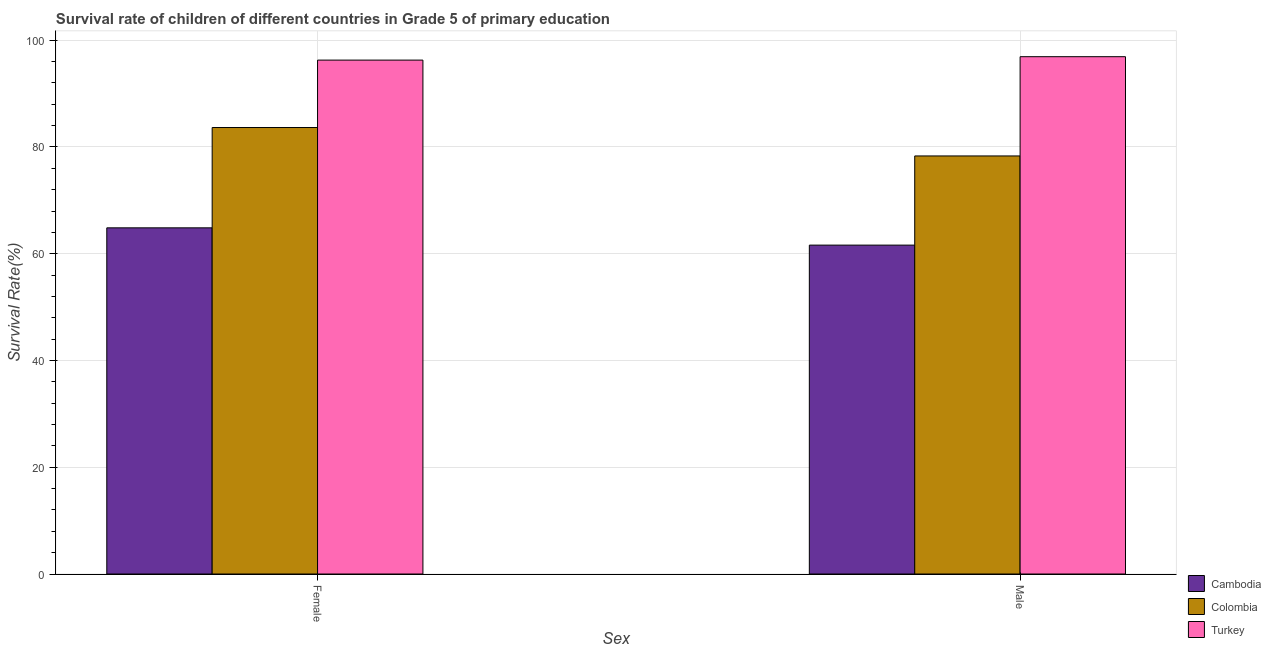How many different coloured bars are there?
Your answer should be compact. 3. How many groups of bars are there?
Offer a terse response. 2. Are the number of bars per tick equal to the number of legend labels?
Provide a short and direct response. Yes. How many bars are there on the 2nd tick from the right?
Make the answer very short. 3. What is the survival rate of female students in primary education in Colombia?
Offer a terse response. 83.64. Across all countries, what is the maximum survival rate of female students in primary education?
Make the answer very short. 96.27. Across all countries, what is the minimum survival rate of male students in primary education?
Offer a terse response. 61.61. In which country was the survival rate of male students in primary education maximum?
Give a very brief answer. Turkey. In which country was the survival rate of female students in primary education minimum?
Offer a very short reply. Cambodia. What is the total survival rate of male students in primary education in the graph?
Provide a short and direct response. 236.85. What is the difference between the survival rate of female students in primary education in Colombia and that in Cambodia?
Provide a short and direct response. 18.79. What is the difference between the survival rate of female students in primary education in Colombia and the survival rate of male students in primary education in Turkey?
Keep it short and to the point. -13.27. What is the average survival rate of male students in primary education per country?
Your response must be concise. 78.95. What is the difference between the survival rate of female students in primary education and survival rate of male students in primary education in Turkey?
Make the answer very short. -0.64. In how many countries, is the survival rate of female students in primary education greater than 76 %?
Your answer should be very brief. 2. What is the ratio of the survival rate of female students in primary education in Colombia to that in Cambodia?
Make the answer very short. 1.29. Is the survival rate of male students in primary education in Cambodia less than that in Turkey?
Provide a short and direct response. Yes. In how many countries, is the survival rate of female students in primary education greater than the average survival rate of female students in primary education taken over all countries?
Give a very brief answer. 2. What does the 3rd bar from the left in Male represents?
Offer a terse response. Turkey. What does the 3rd bar from the right in Female represents?
Ensure brevity in your answer.  Cambodia. Are all the bars in the graph horizontal?
Keep it short and to the point. No. How many countries are there in the graph?
Make the answer very short. 3. Are the values on the major ticks of Y-axis written in scientific E-notation?
Your response must be concise. No. Does the graph contain any zero values?
Your answer should be compact. No. Where does the legend appear in the graph?
Make the answer very short. Bottom right. How are the legend labels stacked?
Give a very brief answer. Vertical. What is the title of the graph?
Give a very brief answer. Survival rate of children of different countries in Grade 5 of primary education. What is the label or title of the X-axis?
Provide a short and direct response. Sex. What is the label or title of the Y-axis?
Keep it short and to the point. Survival Rate(%). What is the Survival Rate(%) in Cambodia in Female?
Offer a terse response. 64.85. What is the Survival Rate(%) in Colombia in Female?
Make the answer very short. 83.64. What is the Survival Rate(%) in Turkey in Female?
Your answer should be compact. 96.27. What is the Survival Rate(%) of Cambodia in Male?
Give a very brief answer. 61.61. What is the Survival Rate(%) in Colombia in Male?
Make the answer very short. 78.32. What is the Survival Rate(%) in Turkey in Male?
Offer a very short reply. 96.91. Across all Sex, what is the maximum Survival Rate(%) in Cambodia?
Ensure brevity in your answer.  64.85. Across all Sex, what is the maximum Survival Rate(%) in Colombia?
Provide a succinct answer. 83.64. Across all Sex, what is the maximum Survival Rate(%) of Turkey?
Offer a terse response. 96.91. Across all Sex, what is the minimum Survival Rate(%) of Cambodia?
Ensure brevity in your answer.  61.61. Across all Sex, what is the minimum Survival Rate(%) in Colombia?
Provide a succinct answer. 78.32. Across all Sex, what is the minimum Survival Rate(%) in Turkey?
Provide a short and direct response. 96.27. What is the total Survival Rate(%) in Cambodia in the graph?
Offer a very short reply. 126.46. What is the total Survival Rate(%) of Colombia in the graph?
Offer a terse response. 161.96. What is the total Survival Rate(%) of Turkey in the graph?
Keep it short and to the point. 193.19. What is the difference between the Survival Rate(%) in Cambodia in Female and that in Male?
Provide a succinct answer. 3.24. What is the difference between the Survival Rate(%) of Colombia in Female and that in Male?
Offer a terse response. 5.32. What is the difference between the Survival Rate(%) of Turkey in Female and that in Male?
Make the answer very short. -0.64. What is the difference between the Survival Rate(%) in Cambodia in Female and the Survival Rate(%) in Colombia in Male?
Your answer should be very brief. -13.47. What is the difference between the Survival Rate(%) in Cambodia in Female and the Survival Rate(%) in Turkey in Male?
Provide a short and direct response. -32.06. What is the difference between the Survival Rate(%) of Colombia in Female and the Survival Rate(%) of Turkey in Male?
Offer a terse response. -13.27. What is the average Survival Rate(%) in Cambodia per Sex?
Provide a short and direct response. 63.23. What is the average Survival Rate(%) in Colombia per Sex?
Give a very brief answer. 80.98. What is the average Survival Rate(%) in Turkey per Sex?
Keep it short and to the point. 96.59. What is the difference between the Survival Rate(%) in Cambodia and Survival Rate(%) in Colombia in Female?
Provide a succinct answer. -18.79. What is the difference between the Survival Rate(%) in Cambodia and Survival Rate(%) in Turkey in Female?
Offer a very short reply. -31.42. What is the difference between the Survival Rate(%) of Colombia and Survival Rate(%) of Turkey in Female?
Offer a terse response. -12.63. What is the difference between the Survival Rate(%) in Cambodia and Survival Rate(%) in Colombia in Male?
Your response must be concise. -16.71. What is the difference between the Survival Rate(%) in Cambodia and Survival Rate(%) in Turkey in Male?
Offer a terse response. -35.3. What is the difference between the Survival Rate(%) of Colombia and Survival Rate(%) of Turkey in Male?
Make the answer very short. -18.59. What is the ratio of the Survival Rate(%) in Cambodia in Female to that in Male?
Give a very brief answer. 1.05. What is the ratio of the Survival Rate(%) in Colombia in Female to that in Male?
Offer a terse response. 1.07. What is the ratio of the Survival Rate(%) in Turkey in Female to that in Male?
Your answer should be compact. 0.99. What is the difference between the highest and the second highest Survival Rate(%) in Cambodia?
Provide a succinct answer. 3.24. What is the difference between the highest and the second highest Survival Rate(%) in Colombia?
Your answer should be very brief. 5.32. What is the difference between the highest and the second highest Survival Rate(%) in Turkey?
Ensure brevity in your answer.  0.64. What is the difference between the highest and the lowest Survival Rate(%) of Cambodia?
Provide a succinct answer. 3.24. What is the difference between the highest and the lowest Survival Rate(%) of Colombia?
Ensure brevity in your answer.  5.32. What is the difference between the highest and the lowest Survival Rate(%) of Turkey?
Provide a short and direct response. 0.64. 